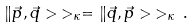<formula> <loc_0><loc_0><loc_500><loc_500>\| \vec { p } , \vec { q } > \, > _ { \kappa } = \| \vec { q } , \vec { p } > \, > _ { \kappa } \, .</formula> 